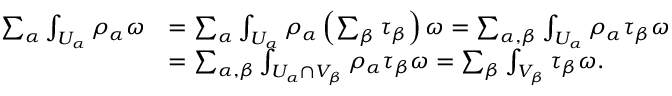Convert formula to latex. <formula><loc_0><loc_0><loc_500><loc_500>\begin{array} { r l } { \sum _ { \alpha } \int _ { U _ { \alpha } } \rho _ { \alpha } \omega } & { = \sum _ { \alpha } \int _ { U _ { \alpha } } \rho _ { \alpha } \left ( \sum _ { \beta } \tau _ { \beta } \right ) \omega = \sum _ { \alpha , \beta } \int _ { U _ { \alpha } } \rho _ { \alpha } \tau _ { \beta } \omega } \\ & { = \sum _ { \alpha , \beta } \int _ { U _ { \alpha } \cap V _ { \beta } } \rho _ { \alpha } \tau _ { \beta } \omega = \sum _ { \beta } \int _ { V _ { \beta } } \tau _ { \beta } \omega . } \end{array}</formula> 